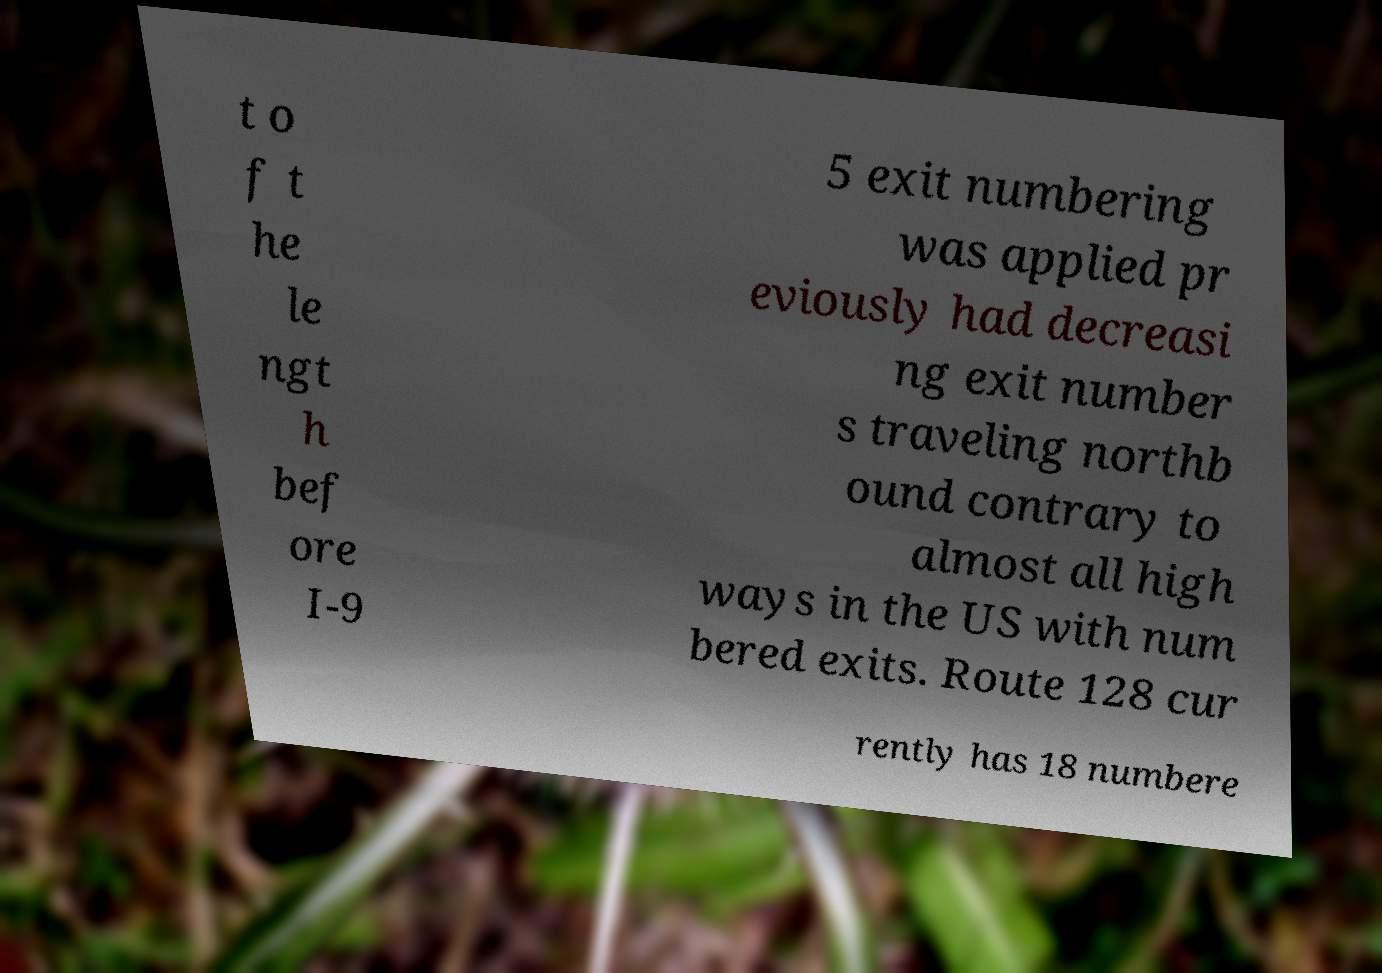I need the written content from this picture converted into text. Can you do that? t o f t he le ngt h bef ore I-9 5 exit numbering was applied pr eviously had decreasi ng exit number s traveling northb ound contrary to almost all high ways in the US with num bered exits. Route 128 cur rently has 18 numbere 